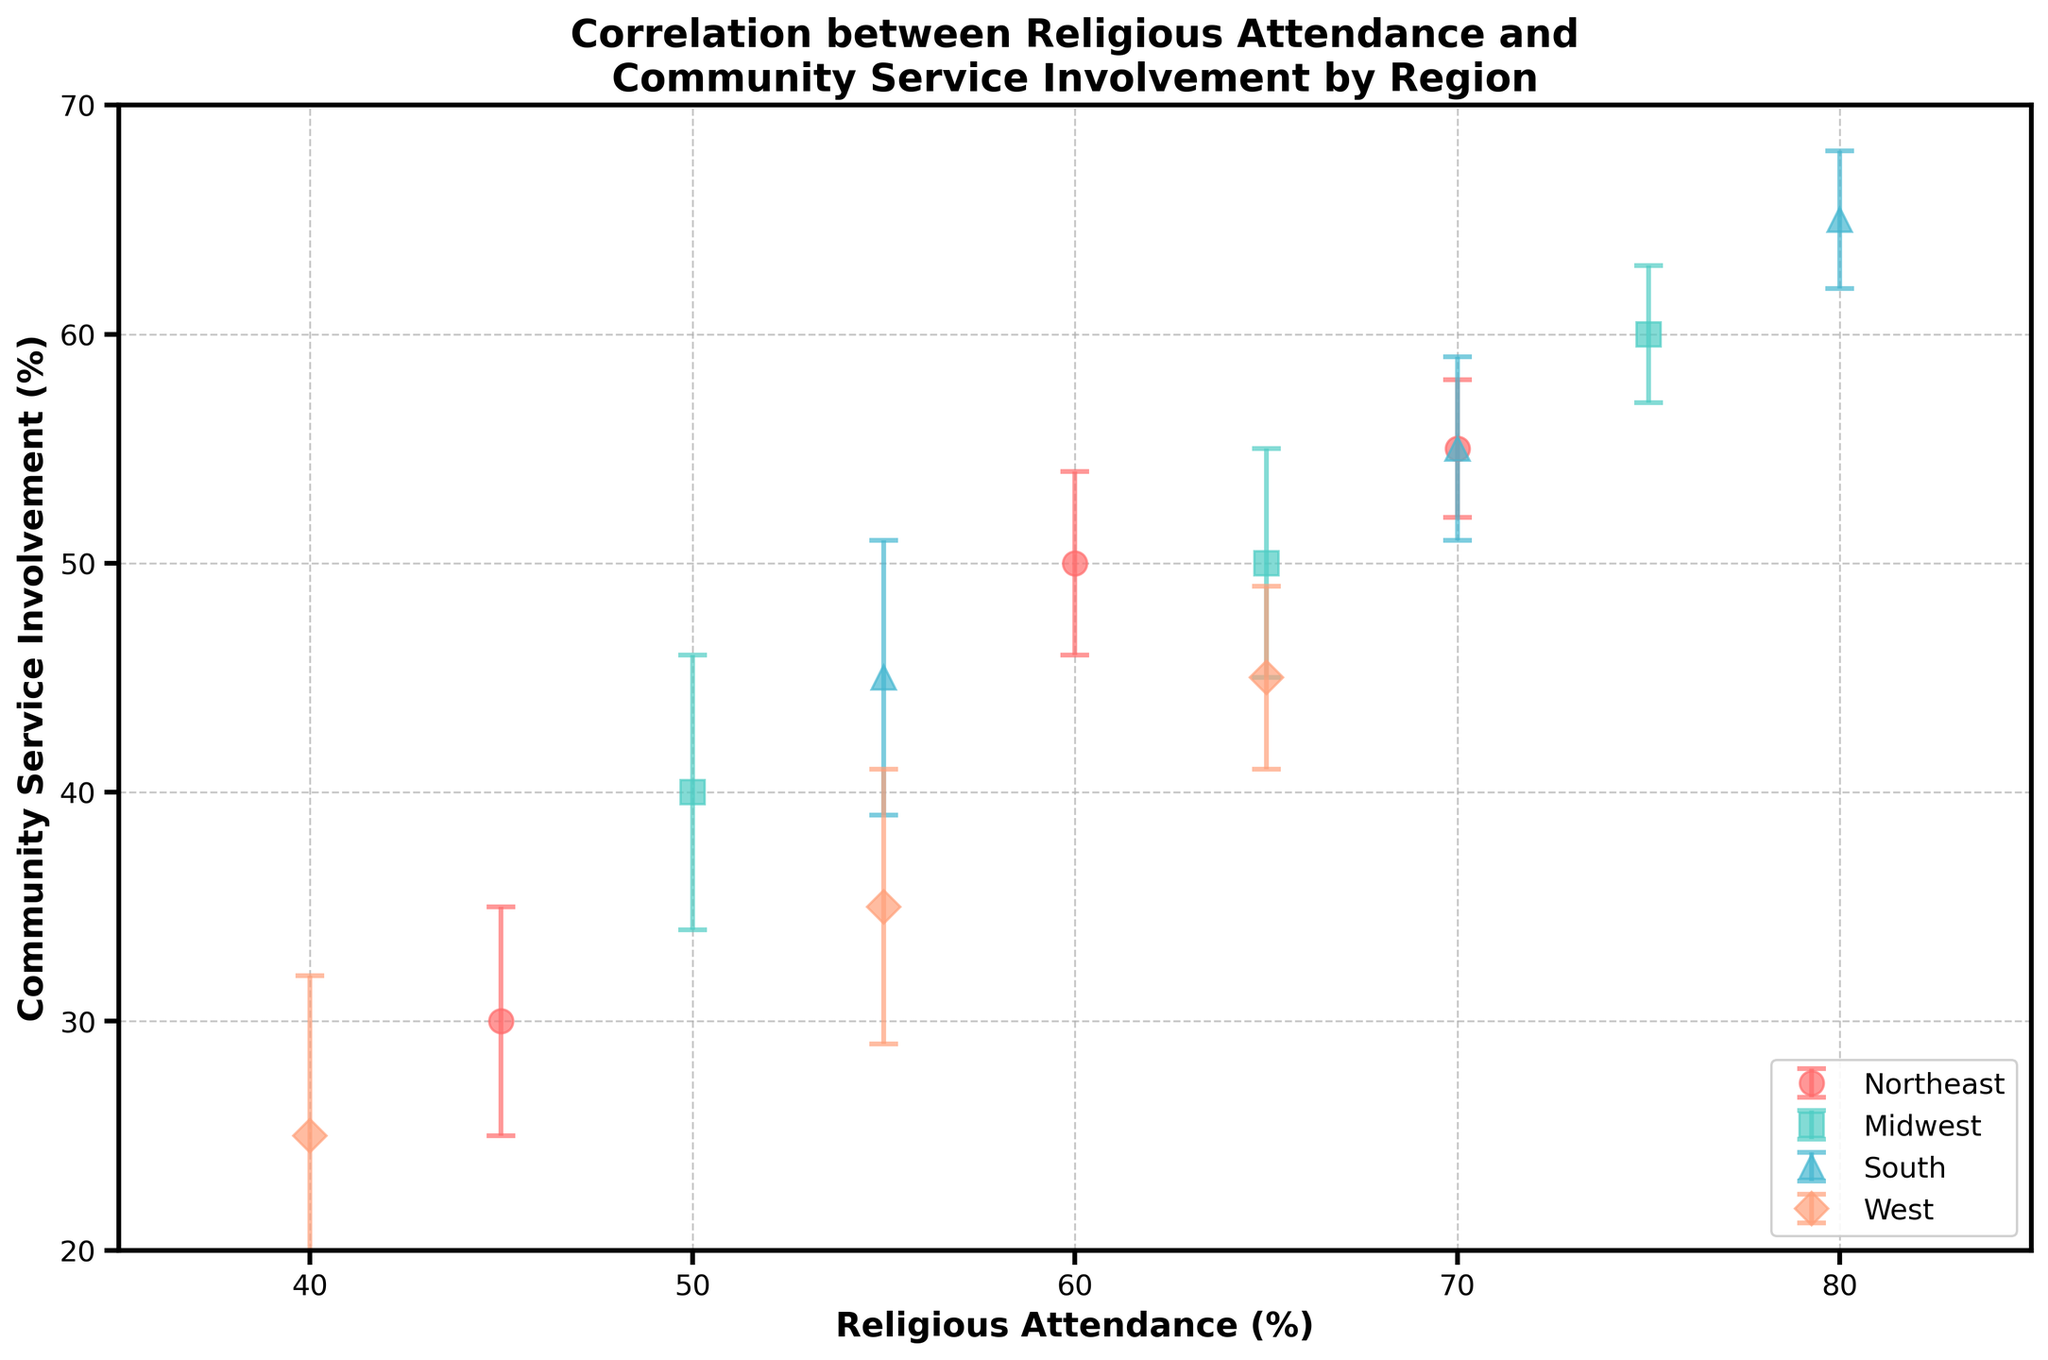What is the title of the figure? The title is usually located at the top of the figure. Here, the title is "Correlation between Religious Attendance and Community Service Involvement by Region," which explains what the plot is about and the specific aspect it addresses.
Answer: Correlation between Religious Attendance and Community Service Involvement by Region Which region has the greatest range of religious attendance? To determine this, look at the horizontal spread of the data points for each region from the smallest to the largest value. The South region ranges from 55 to 80, giving a span of 25. Other regions have smaller ranges.
Answer: South What is the mean community service involvement for the Midwest region? The values for the Midwest are 40, 50, and 60. The mean can be calculated by summing these values and dividing by the number of data points: (40 + 50 + 60) / 3 = 150 / 3 = 50.
Answer: 50 Which region has the smallest margin of error (standard error) for its community service involvement? Check the lengths of the error bars for each region. The smallest error bar is in the Northeast, where one endpoint has a standard error of 3.
Answer: Northeast How do religious attendance and community service involvement correlate in the South region? Correlation can be identified by the general trend of data points. In the South, as religious attendance increases (55 to 80), community service involvement also increases (45 to 65), indicating a positive correlation.
Answer: Positive correlation What is the difference in community service involvement between the highest religious attendance in the West and the Midwest? For the West, the highest religious attendance is 65 with a community service involvement of 45. For the Midwest, the highest religious attendance is 75 with a community service involvement of 60. Difference: 60 - 45 = 15.
Answer: 15 Which region shows the least variation in community service involvement? Variation is indicated by the spread of points along the vertical axis. The Northeast data points for community service involvement spread from 30 to 55, which is a range of 25. This is the smallest range among the regions.
Answer: Northeast What is the maximum community service involvement observed in the entire dataset? Look for the highest point on the vertical axis among all regions. The maximum community service involvement observed is 65, which appears for the South region.
Answer: 65 Compare the religious attendance levels in the Northeast and West regions. Which has higher attendance on average? In the Northeast, religious attendance levels are 45, 60, and 70, giving an average of (45 + 60 + 70) / 3 = 58.33. In the West, levels are 40, 55, and 65, giving an average of (40 + 55 + 65) / 3 = 53.33. Northeast has higher average attendance.
Answer: Northeast Which region exhibits the highest variability in community service involvement? Variability can be assessed by looking at standard errors. The West shows the largest standard error (up to 7), indicating higher variability in community service involvement.
Answer: West 